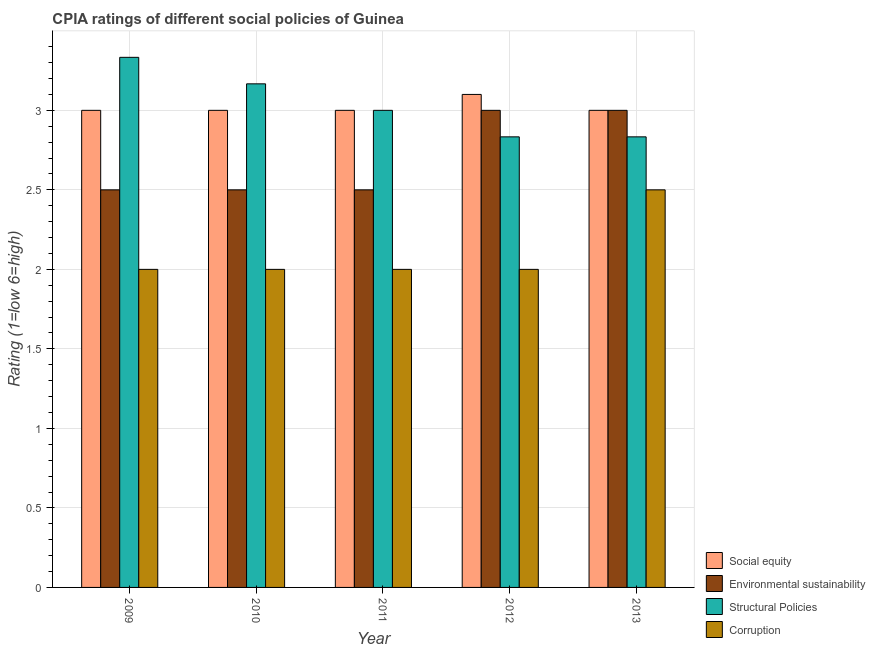How many groups of bars are there?
Keep it short and to the point. 5. Are the number of bars per tick equal to the number of legend labels?
Your answer should be very brief. Yes. Are the number of bars on each tick of the X-axis equal?
Offer a terse response. Yes. How many bars are there on the 4th tick from the left?
Your answer should be very brief. 4. How many bars are there on the 3rd tick from the right?
Provide a succinct answer. 4. Across all years, what is the minimum cpia rating of corruption?
Your response must be concise. 2. In which year was the cpia rating of structural policies minimum?
Provide a succinct answer. 2012. What is the total cpia rating of environmental sustainability in the graph?
Make the answer very short. 13.5. What is the difference between the cpia rating of social equity in 2010 and that in 2012?
Give a very brief answer. -0.1. What is the difference between the cpia rating of structural policies in 2009 and the cpia rating of social equity in 2012?
Your answer should be very brief. 0.5. What is the average cpia rating of structural policies per year?
Offer a terse response. 3.03. Is the difference between the cpia rating of corruption in 2011 and 2012 greater than the difference between the cpia rating of social equity in 2011 and 2012?
Ensure brevity in your answer.  No. What is the difference between the highest and the second highest cpia rating of structural policies?
Ensure brevity in your answer.  0.17. What is the difference between the highest and the lowest cpia rating of social equity?
Provide a succinct answer. 0.1. What does the 4th bar from the left in 2012 represents?
Provide a short and direct response. Corruption. What does the 1st bar from the right in 2010 represents?
Give a very brief answer. Corruption. Is it the case that in every year, the sum of the cpia rating of social equity and cpia rating of environmental sustainability is greater than the cpia rating of structural policies?
Provide a succinct answer. Yes. How many years are there in the graph?
Make the answer very short. 5. Are the values on the major ticks of Y-axis written in scientific E-notation?
Offer a terse response. No. Does the graph contain any zero values?
Make the answer very short. No. Does the graph contain grids?
Offer a very short reply. Yes. How many legend labels are there?
Provide a succinct answer. 4. How are the legend labels stacked?
Your answer should be compact. Vertical. What is the title of the graph?
Offer a terse response. CPIA ratings of different social policies of Guinea. What is the Rating (1=low 6=high) in Environmental sustainability in 2009?
Provide a succinct answer. 2.5. What is the Rating (1=low 6=high) in Structural Policies in 2009?
Provide a short and direct response. 3.33. What is the Rating (1=low 6=high) of Environmental sustainability in 2010?
Your answer should be compact. 2.5. What is the Rating (1=low 6=high) of Structural Policies in 2010?
Provide a short and direct response. 3.17. What is the Rating (1=low 6=high) of Corruption in 2010?
Your response must be concise. 2. What is the Rating (1=low 6=high) in Social equity in 2011?
Ensure brevity in your answer.  3. What is the Rating (1=low 6=high) of Structural Policies in 2011?
Provide a short and direct response. 3. What is the Rating (1=low 6=high) of Environmental sustainability in 2012?
Provide a succinct answer. 3. What is the Rating (1=low 6=high) in Structural Policies in 2012?
Your response must be concise. 2.83. What is the Rating (1=low 6=high) of Corruption in 2012?
Your answer should be very brief. 2. What is the Rating (1=low 6=high) in Environmental sustainability in 2013?
Your answer should be compact. 3. What is the Rating (1=low 6=high) of Structural Policies in 2013?
Ensure brevity in your answer.  2.83. What is the Rating (1=low 6=high) in Corruption in 2013?
Keep it short and to the point. 2.5. Across all years, what is the maximum Rating (1=low 6=high) in Social equity?
Your answer should be compact. 3.1. Across all years, what is the maximum Rating (1=low 6=high) of Environmental sustainability?
Ensure brevity in your answer.  3. Across all years, what is the maximum Rating (1=low 6=high) of Structural Policies?
Your response must be concise. 3.33. Across all years, what is the minimum Rating (1=low 6=high) of Social equity?
Your answer should be very brief. 3. Across all years, what is the minimum Rating (1=low 6=high) in Structural Policies?
Offer a terse response. 2.83. What is the total Rating (1=low 6=high) in Social equity in the graph?
Keep it short and to the point. 15.1. What is the total Rating (1=low 6=high) of Structural Policies in the graph?
Your answer should be very brief. 15.17. What is the difference between the Rating (1=low 6=high) in Environmental sustainability in 2009 and that in 2011?
Your response must be concise. 0. What is the difference between the Rating (1=low 6=high) in Structural Policies in 2009 and that in 2011?
Your response must be concise. 0.33. What is the difference between the Rating (1=low 6=high) of Corruption in 2009 and that in 2011?
Ensure brevity in your answer.  0. What is the difference between the Rating (1=low 6=high) in Environmental sustainability in 2009 and that in 2012?
Give a very brief answer. -0.5. What is the difference between the Rating (1=low 6=high) in Structural Policies in 2009 and that in 2012?
Offer a terse response. 0.5. What is the difference between the Rating (1=low 6=high) of Environmental sustainability in 2009 and that in 2013?
Offer a terse response. -0.5. What is the difference between the Rating (1=low 6=high) of Structural Policies in 2009 and that in 2013?
Your answer should be compact. 0.5. What is the difference between the Rating (1=low 6=high) of Corruption in 2009 and that in 2013?
Make the answer very short. -0.5. What is the difference between the Rating (1=low 6=high) of Structural Policies in 2010 and that in 2011?
Your answer should be compact. 0.17. What is the difference between the Rating (1=low 6=high) of Social equity in 2010 and that in 2012?
Your response must be concise. -0.1. What is the difference between the Rating (1=low 6=high) in Environmental sustainability in 2010 and that in 2012?
Provide a succinct answer. -0.5. What is the difference between the Rating (1=low 6=high) of Corruption in 2010 and that in 2012?
Keep it short and to the point. 0. What is the difference between the Rating (1=low 6=high) of Social equity in 2010 and that in 2013?
Make the answer very short. 0. What is the difference between the Rating (1=low 6=high) in Structural Policies in 2011 and that in 2012?
Provide a succinct answer. 0.17. What is the difference between the Rating (1=low 6=high) of Structural Policies in 2011 and that in 2013?
Your answer should be compact. 0.17. What is the difference between the Rating (1=low 6=high) in Corruption in 2011 and that in 2013?
Provide a short and direct response. -0.5. What is the difference between the Rating (1=low 6=high) of Social equity in 2012 and that in 2013?
Make the answer very short. 0.1. What is the difference between the Rating (1=low 6=high) in Social equity in 2009 and the Rating (1=low 6=high) in Structural Policies in 2010?
Provide a short and direct response. -0.17. What is the difference between the Rating (1=low 6=high) of Social equity in 2009 and the Rating (1=low 6=high) of Corruption in 2010?
Provide a succinct answer. 1. What is the difference between the Rating (1=low 6=high) in Social equity in 2009 and the Rating (1=low 6=high) in Environmental sustainability in 2011?
Provide a succinct answer. 0.5. What is the difference between the Rating (1=low 6=high) in Environmental sustainability in 2009 and the Rating (1=low 6=high) in Structural Policies in 2011?
Provide a succinct answer. -0.5. What is the difference between the Rating (1=low 6=high) of Environmental sustainability in 2009 and the Rating (1=low 6=high) of Corruption in 2011?
Provide a succinct answer. 0.5. What is the difference between the Rating (1=low 6=high) in Structural Policies in 2009 and the Rating (1=low 6=high) in Corruption in 2011?
Your response must be concise. 1.33. What is the difference between the Rating (1=low 6=high) of Social equity in 2009 and the Rating (1=low 6=high) of Environmental sustainability in 2012?
Offer a very short reply. 0. What is the difference between the Rating (1=low 6=high) of Social equity in 2009 and the Rating (1=low 6=high) of Structural Policies in 2012?
Your response must be concise. 0.17. What is the difference between the Rating (1=low 6=high) of Environmental sustainability in 2009 and the Rating (1=low 6=high) of Corruption in 2012?
Offer a terse response. 0.5. What is the difference between the Rating (1=low 6=high) of Social equity in 2009 and the Rating (1=low 6=high) of Environmental sustainability in 2013?
Make the answer very short. 0. What is the difference between the Rating (1=low 6=high) of Social equity in 2009 and the Rating (1=low 6=high) of Structural Policies in 2013?
Make the answer very short. 0.17. What is the difference between the Rating (1=low 6=high) of Social equity in 2009 and the Rating (1=low 6=high) of Corruption in 2013?
Make the answer very short. 0.5. What is the difference between the Rating (1=low 6=high) of Environmental sustainability in 2009 and the Rating (1=low 6=high) of Structural Policies in 2013?
Provide a short and direct response. -0.33. What is the difference between the Rating (1=low 6=high) of Structural Policies in 2009 and the Rating (1=low 6=high) of Corruption in 2013?
Your response must be concise. 0.83. What is the difference between the Rating (1=low 6=high) of Social equity in 2010 and the Rating (1=low 6=high) of Environmental sustainability in 2011?
Give a very brief answer. 0.5. What is the difference between the Rating (1=low 6=high) in Social equity in 2010 and the Rating (1=low 6=high) in Structural Policies in 2011?
Keep it short and to the point. 0. What is the difference between the Rating (1=low 6=high) in Environmental sustainability in 2010 and the Rating (1=low 6=high) in Structural Policies in 2011?
Offer a very short reply. -0.5. What is the difference between the Rating (1=low 6=high) in Environmental sustainability in 2010 and the Rating (1=low 6=high) in Corruption in 2011?
Your response must be concise. 0.5. What is the difference between the Rating (1=low 6=high) of Structural Policies in 2010 and the Rating (1=low 6=high) of Corruption in 2011?
Offer a very short reply. 1.17. What is the difference between the Rating (1=low 6=high) in Environmental sustainability in 2010 and the Rating (1=low 6=high) in Corruption in 2012?
Provide a short and direct response. 0.5. What is the difference between the Rating (1=low 6=high) in Social equity in 2010 and the Rating (1=low 6=high) in Environmental sustainability in 2013?
Your answer should be very brief. 0. What is the difference between the Rating (1=low 6=high) in Social equity in 2010 and the Rating (1=low 6=high) in Corruption in 2013?
Make the answer very short. 0.5. What is the difference between the Rating (1=low 6=high) in Environmental sustainability in 2010 and the Rating (1=low 6=high) in Corruption in 2013?
Your answer should be very brief. 0. What is the difference between the Rating (1=low 6=high) of Structural Policies in 2010 and the Rating (1=low 6=high) of Corruption in 2013?
Your answer should be compact. 0.67. What is the difference between the Rating (1=low 6=high) of Social equity in 2011 and the Rating (1=low 6=high) of Corruption in 2012?
Your answer should be compact. 1. What is the difference between the Rating (1=low 6=high) of Environmental sustainability in 2011 and the Rating (1=low 6=high) of Corruption in 2012?
Offer a terse response. 0.5. What is the difference between the Rating (1=low 6=high) in Social equity in 2011 and the Rating (1=low 6=high) in Environmental sustainability in 2013?
Your answer should be compact. 0. What is the difference between the Rating (1=low 6=high) in Social equity in 2011 and the Rating (1=low 6=high) in Structural Policies in 2013?
Your answer should be compact. 0.17. What is the difference between the Rating (1=low 6=high) of Social equity in 2011 and the Rating (1=low 6=high) of Corruption in 2013?
Ensure brevity in your answer.  0.5. What is the difference between the Rating (1=low 6=high) in Environmental sustainability in 2011 and the Rating (1=low 6=high) in Structural Policies in 2013?
Offer a terse response. -0.33. What is the difference between the Rating (1=low 6=high) in Environmental sustainability in 2011 and the Rating (1=low 6=high) in Corruption in 2013?
Make the answer very short. 0. What is the difference between the Rating (1=low 6=high) of Social equity in 2012 and the Rating (1=low 6=high) of Structural Policies in 2013?
Offer a very short reply. 0.27. What is the difference between the Rating (1=low 6=high) in Social equity in 2012 and the Rating (1=low 6=high) in Corruption in 2013?
Provide a short and direct response. 0.6. What is the difference between the Rating (1=low 6=high) of Environmental sustainability in 2012 and the Rating (1=low 6=high) of Structural Policies in 2013?
Your answer should be very brief. 0.17. What is the difference between the Rating (1=low 6=high) of Environmental sustainability in 2012 and the Rating (1=low 6=high) of Corruption in 2013?
Offer a very short reply. 0.5. What is the average Rating (1=low 6=high) in Social equity per year?
Make the answer very short. 3.02. What is the average Rating (1=low 6=high) in Environmental sustainability per year?
Keep it short and to the point. 2.7. What is the average Rating (1=low 6=high) of Structural Policies per year?
Provide a short and direct response. 3.03. What is the average Rating (1=low 6=high) in Corruption per year?
Your answer should be very brief. 2.1. In the year 2009, what is the difference between the Rating (1=low 6=high) in Social equity and Rating (1=low 6=high) in Environmental sustainability?
Ensure brevity in your answer.  0.5. In the year 2009, what is the difference between the Rating (1=low 6=high) in Social equity and Rating (1=low 6=high) in Structural Policies?
Make the answer very short. -0.33. In the year 2009, what is the difference between the Rating (1=low 6=high) in Social equity and Rating (1=low 6=high) in Corruption?
Offer a terse response. 1. In the year 2009, what is the difference between the Rating (1=low 6=high) of Environmental sustainability and Rating (1=low 6=high) of Structural Policies?
Your answer should be very brief. -0.83. In the year 2009, what is the difference between the Rating (1=low 6=high) of Structural Policies and Rating (1=low 6=high) of Corruption?
Your answer should be very brief. 1.33. In the year 2010, what is the difference between the Rating (1=low 6=high) in Social equity and Rating (1=low 6=high) in Environmental sustainability?
Make the answer very short. 0.5. In the year 2010, what is the difference between the Rating (1=low 6=high) of Social equity and Rating (1=low 6=high) of Structural Policies?
Offer a terse response. -0.17. In the year 2010, what is the difference between the Rating (1=low 6=high) of Social equity and Rating (1=low 6=high) of Corruption?
Ensure brevity in your answer.  1. In the year 2010, what is the difference between the Rating (1=low 6=high) in Environmental sustainability and Rating (1=low 6=high) in Structural Policies?
Ensure brevity in your answer.  -0.67. In the year 2011, what is the difference between the Rating (1=low 6=high) of Social equity and Rating (1=low 6=high) of Environmental sustainability?
Offer a terse response. 0.5. In the year 2011, what is the difference between the Rating (1=low 6=high) in Environmental sustainability and Rating (1=low 6=high) in Corruption?
Provide a short and direct response. 0.5. In the year 2012, what is the difference between the Rating (1=low 6=high) of Social equity and Rating (1=low 6=high) of Structural Policies?
Your answer should be very brief. 0.27. In the year 2012, what is the difference between the Rating (1=low 6=high) in Environmental sustainability and Rating (1=low 6=high) in Structural Policies?
Your response must be concise. 0.17. In the year 2012, what is the difference between the Rating (1=low 6=high) of Environmental sustainability and Rating (1=low 6=high) of Corruption?
Your answer should be very brief. 1. In the year 2012, what is the difference between the Rating (1=low 6=high) of Structural Policies and Rating (1=low 6=high) of Corruption?
Provide a short and direct response. 0.83. In the year 2013, what is the difference between the Rating (1=low 6=high) of Social equity and Rating (1=low 6=high) of Environmental sustainability?
Offer a very short reply. 0. In the year 2013, what is the difference between the Rating (1=low 6=high) in Social equity and Rating (1=low 6=high) in Structural Policies?
Make the answer very short. 0.17. In the year 2013, what is the difference between the Rating (1=low 6=high) in Social equity and Rating (1=low 6=high) in Corruption?
Keep it short and to the point. 0.5. In the year 2013, what is the difference between the Rating (1=low 6=high) of Environmental sustainability and Rating (1=low 6=high) of Structural Policies?
Your answer should be very brief. 0.17. In the year 2013, what is the difference between the Rating (1=low 6=high) of Environmental sustainability and Rating (1=low 6=high) of Corruption?
Provide a succinct answer. 0.5. In the year 2013, what is the difference between the Rating (1=low 6=high) in Structural Policies and Rating (1=low 6=high) in Corruption?
Your answer should be very brief. 0.33. What is the ratio of the Rating (1=low 6=high) in Social equity in 2009 to that in 2010?
Provide a short and direct response. 1. What is the ratio of the Rating (1=low 6=high) in Structural Policies in 2009 to that in 2010?
Your answer should be compact. 1.05. What is the ratio of the Rating (1=low 6=high) in Environmental sustainability in 2009 to that in 2011?
Offer a terse response. 1. What is the ratio of the Rating (1=low 6=high) of Structural Policies in 2009 to that in 2011?
Ensure brevity in your answer.  1.11. What is the ratio of the Rating (1=low 6=high) of Corruption in 2009 to that in 2011?
Your answer should be compact. 1. What is the ratio of the Rating (1=low 6=high) of Social equity in 2009 to that in 2012?
Ensure brevity in your answer.  0.97. What is the ratio of the Rating (1=low 6=high) in Environmental sustainability in 2009 to that in 2012?
Your answer should be very brief. 0.83. What is the ratio of the Rating (1=low 6=high) in Structural Policies in 2009 to that in 2012?
Offer a very short reply. 1.18. What is the ratio of the Rating (1=low 6=high) in Structural Policies in 2009 to that in 2013?
Offer a very short reply. 1.18. What is the ratio of the Rating (1=low 6=high) in Structural Policies in 2010 to that in 2011?
Keep it short and to the point. 1.06. What is the ratio of the Rating (1=low 6=high) in Corruption in 2010 to that in 2011?
Give a very brief answer. 1. What is the ratio of the Rating (1=low 6=high) in Structural Policies in 2010 to that in 2012?
Make the answer very short. 1.12. What is the ratio of the Rating (1=low 6=high) of Environmental sustainability in 2010 to that in 2013?
Provide a succinct answer. 0.83. What is the ratio of the Rating (1=low 6=high) of Structural Policies in 2010 to that in 2013?
Provide a succinct answer. 1.12. What is the ratio of the Rating (1=low 6=high) of Corruption in 2010 to that in 2013?
Make the answer very short. 0.8. What is the ratio of the Rating (1=low 6=high) in Social equity in 2011 to that in 2012?
Ensure brevity in your answer.  0.97. What is the ratio of the Rating (1=low 6=high) in Structural Policies in 2011 to that in 2012?
Your answer should be compact. 1.06. What is the ratio of the Rating (1=low 6=high) of Social equity in 2011 to that in 2013?
Offer a very short reply. 1. What is the ratio of the Rating (1=low 6=high) in Environmental sustainability in 2011 to that in 2013?
Keep it short and to the point. 0.83. What is the ratio of the Rating (1=low 6=high) in Structural Policies in 2011 to that in 2013?
Offer a terse response. 1.06. What is the ratio of the Rating (1=low 6=high) in Corruption in 2011 to that in 2013?
Your answer should be compact. 0.8. What is the ratio of the Rating (1=low 6=high) of Social equity in 2012 to that in 2013?
Provide a short and direct response. 1.03. What is the ratio of the Rating (1=low 6=high) of Corruption in 2012 to that in 2013?
Your response must be concise. 0.8. What is the difference between the highest and the second highest Rating (1=low 6=high) in Environmental sustainability?
Ensure brevity in your answer.  0. What is the difference between the highest and the second highest Rating (1=low 6=high) of Structural Policies?
Offer a terse response. 0.17. What is the difference between the highest and the lowest Rating (1=low 6=high) in Social equity?
Your answer should be very brief. 0.1. What is the difference between the highest and the lowest Rating (1=low 6=high) in Environmental sustainability?
Your answer should be very brief. 0.5. What is the difference between the highest and the lowest Rating (1=low 6=high) of Structural Policies?
Offer a terse response. 0.5. What is the difference between the highest and the lowest Rating (1=low 6=high) of Corruption?
Your answer should be compact. 0.5. 